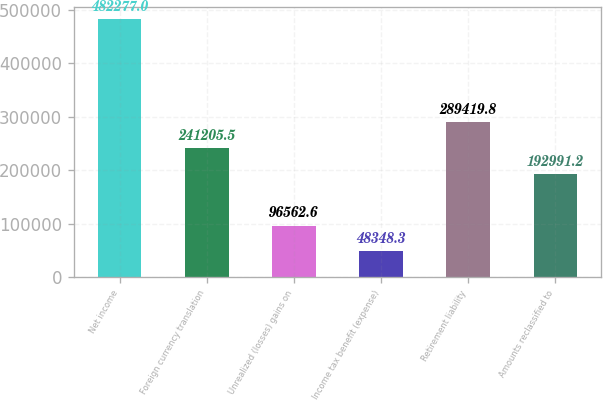Convert chart. <chart><loc_0><loc_0><loc_500><loc_500><bar_chart><fcel>Net income<fcel>Foreign currency translation<fcel>Unrealized (losses) gains on<fcel>Income tax benefit (expense)<fcel>Retirement liability<fcel>Amounts reclassified to<nl><fcel>482277<fcel>241206<fcel>96562.6<fcel>48348.3<fcel>289420<fcel>192991<nl></chart> 